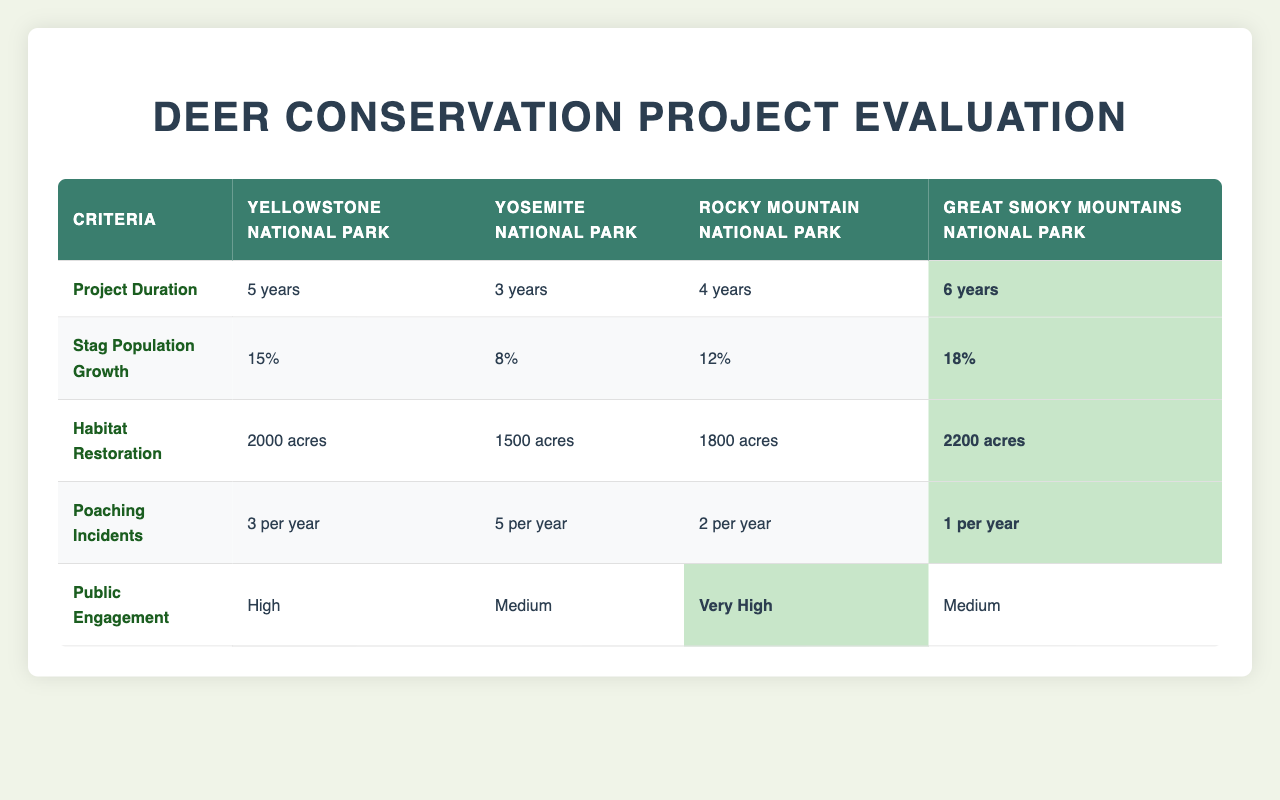What is the project duration for the Great Smoky Mountains National Park? The table directly states that the project duration for the Great Smoky Mountains National Park is 6 years.
Answer: 6 years Which park has the highest stag population growth? By looking at the table, the Great Smoky Mountains National Park has a stag population growth of 18%, which is the highest among all options.
Answer: Great Smoky Mountains National Park How many acres were restored in Yosemite National Park? The table specifies that habitat restoration in Yosemite National Park was 1500 acres.
Answer: 1500 acres Are there more poaching incidents in Yellowstone National Park compared to Rocky Mountain National Park? The table shows that Yellowstone National Park has 3 poaching incidents per year, while Rocky Mountain National Park has 2. Since 3 is greater than 2, the answer is yes.
Answer: Yes What is the average stag population growth across all parks? To find the average stag population growth, first sum the percentages: 15% (Yellowstone) + 8% (Yosemite) + 12% (Rocky Mountain) + 18% (Great Smoky Mountains) = 53%. Then divide by the number of parks (4): 53% / 4 = 13.25%.
Answer: 13.25% Which park has the most habitat restoration and what is the amount? The table indicates that the Great Smoky Mountains National Park has the most habitat restoration at 2200 acres.
Answer: Great Smoky Mountains National Park, 2200 acres Does Rocky Mountain National Park have a higher public engagement level compared to Yosemite National Park? According to the table, the public engagement level for Rocky Mountain National Park is "Very High," while Yosemite National Park's is "Medium." Since "Very High" is greater than "Medium," the answer is yes.
Answer: Yes What is the difference in poaching incidents between the park with the least and most poaching incidents? The Great Smoky Mountains National Park has the least poaching incidents (1 per year), and Yosemite National Park has the most (5 per year). The difference is 5 - 1 = 4.
Answer: 4 Which two parks have a medium level of public engagement? The table highlights that Yosemite National Park and Great Smoky Mountains National Park both have "Medium" public engagement levels.
Answer: Yosemite National Park, Great Smoky Mountains National Park 